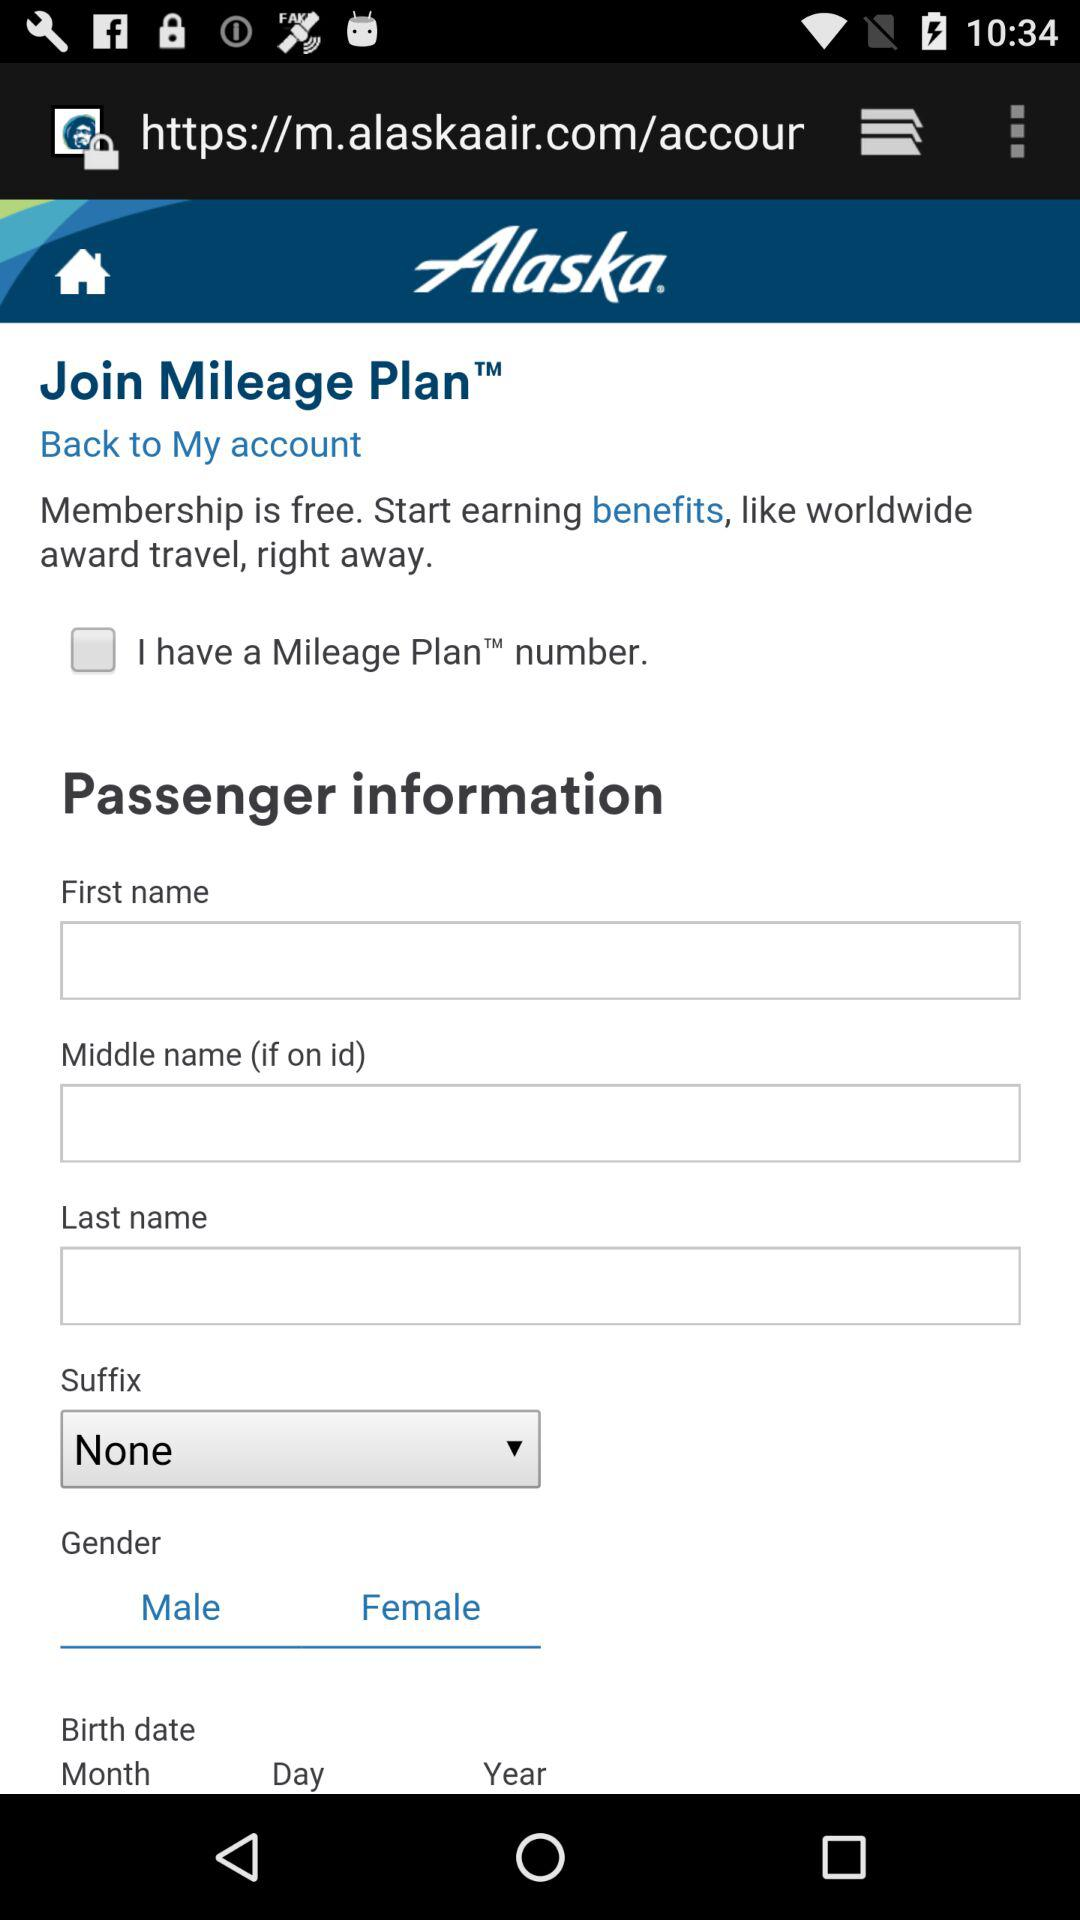What is the status of "I have a Mileage Plan™ number."? The status is "off". 